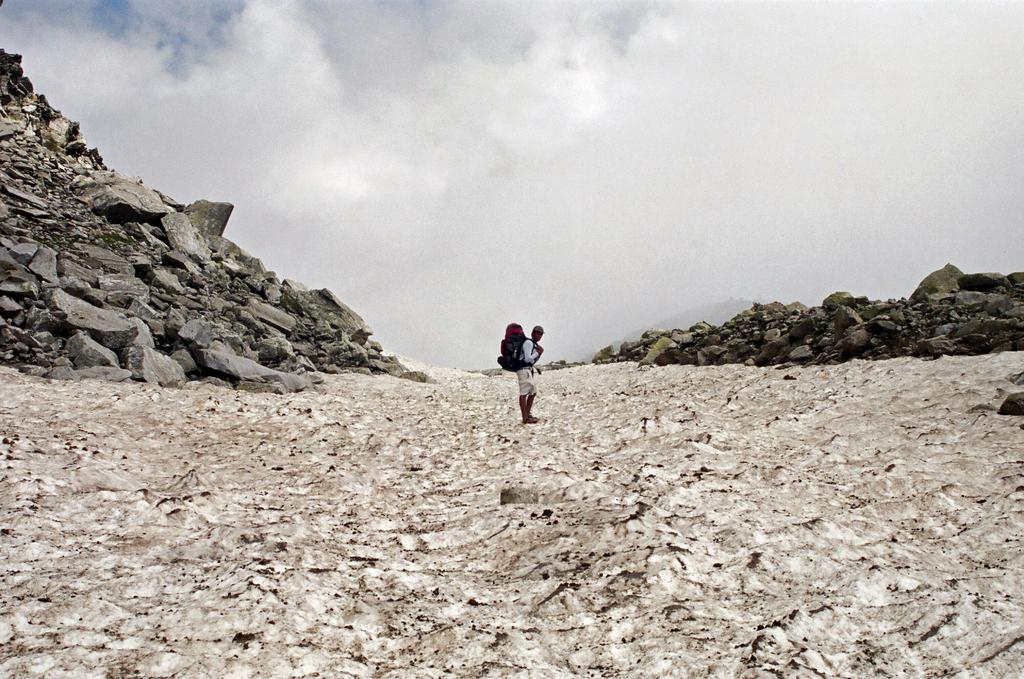What is the main subject in the center of the image? There is a person standing in the center of the image. What can be seen on both sides of the person? There are stones on both sides of the image. What is visible in the background of the image? There are clouds and the sky visible in the background of the image. How many women are interacting with the clam in the image? There are no women or clams present in the image. What type of bait is being used by the person in the image? There is no bait visible in the image, and it is not clear if the person is engaged in any activity that would require bait. 